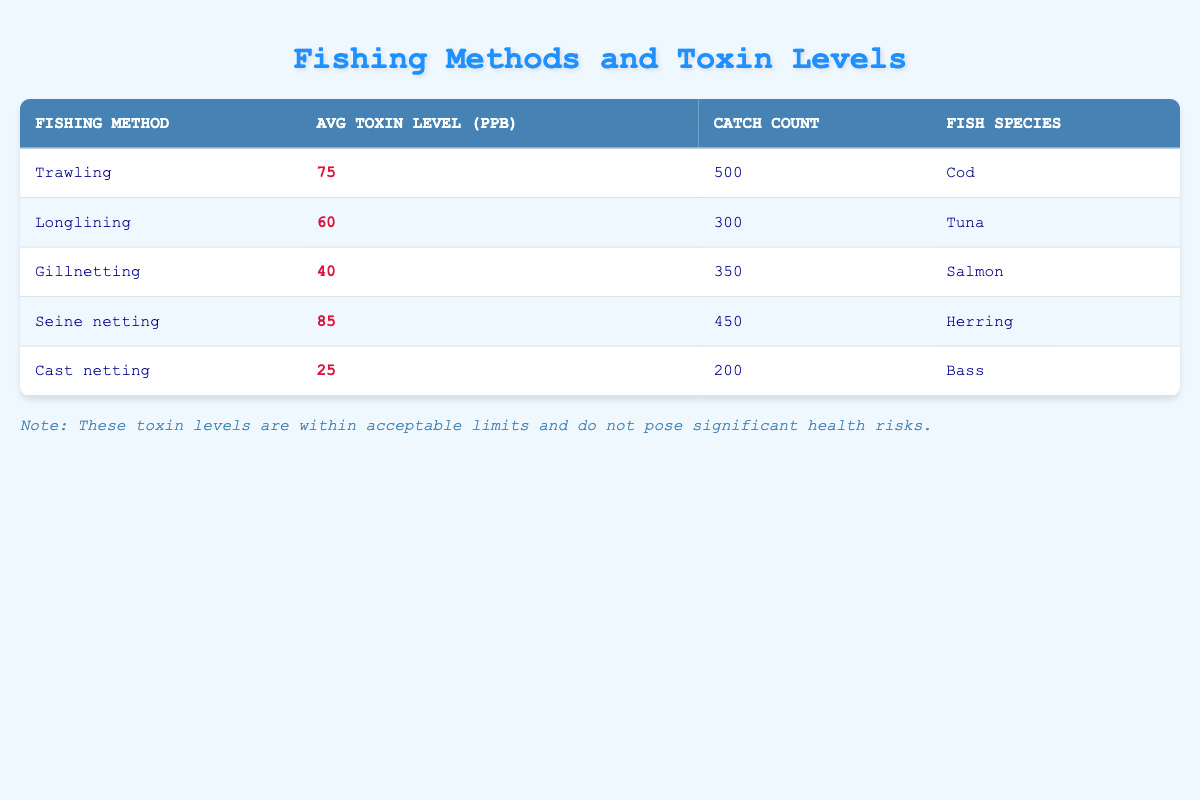What is the average toxin level for all fishing methods listed? To find the average toxin level, we sum the average toxin levels from all fishing methods: (75 + 60 + 40 + 85 + 25) = 285. There are 5 methods, so we divide the total by 5: 285 / 5 = 57.
Answer: 57 Which fishing method has the highest average toxin level? By reviewing the Avg Toxin Level column, we identify that Seine netting has the highest value at 85 ppb, which is greater than all other methods.
Answer: Seine netting What is the total catch count for all fishing methods combined? We add up the catch counts from each method: (500 + 300 + 350 + 450 + 200) = 1800. This sum gives us the total catch count.
Answer: 1800 Is there a fishing method with an average toxin level below 30 ppb? By examining the Avg Toxin Level column, the lowest value presented is 25 ppb from Cast netting. Since there is a number lower than 30 ppb, the answer is yes.
Answer: Yes Which fish species corresponds to the fishing method with the lowest average toxin level? Reviewing the table, we find that Cast netting has the lowest Avg Toxin Level of 25 ppb. The fish species listed alongside it is Bass.
Answer: Bass If we compare the average toxin levels of Trawling and Gillnetting, which is higher and by how much? Trawling has an Avg Toxin Level of 75 ppb and Gillnetting has 40 ppb. The difference between them is calculated as 75 - 40 = 35 ppb, so Trawling is higher by 35 ppb.
Answer: Trawling is higher by 35 ppb What percentage of the total catch is represented by the catch of Longlining? The catch count for Longlining is 300, and the total catch count is 1800. To find the percentage: (300 / 1800) * 100 = 16.67%.
Answer: 16.67% Do all fishing methods yield fish species from the same family? The fish species listed (Cod, Tuna, Salmon, Herring, Bass) belong to different families. Since these fish are from various species and families, the answer is no.
Answer: No How many more fish were caught using Trawling compared to Cast netting? The catch count for Trawling is 500 and for Cast netting is 200. To find the difference: 500 - 200 = 300. Hence, 300 more fish were caught using Trawling.
Answer: 300 